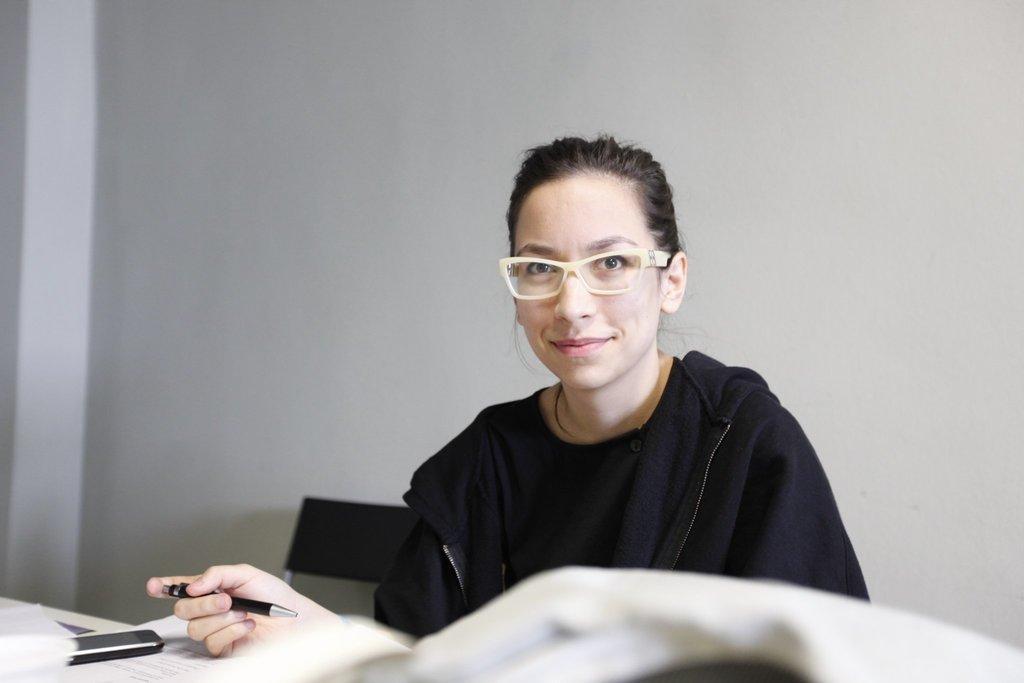Please provide a concise description of this image. There is a woman in black color coat, sitting on a chair and holding a pen and placing hand on the book, which is on the table, near a mobile which is on the book. On the table, there are other objects. In the background, there is a white wall. 